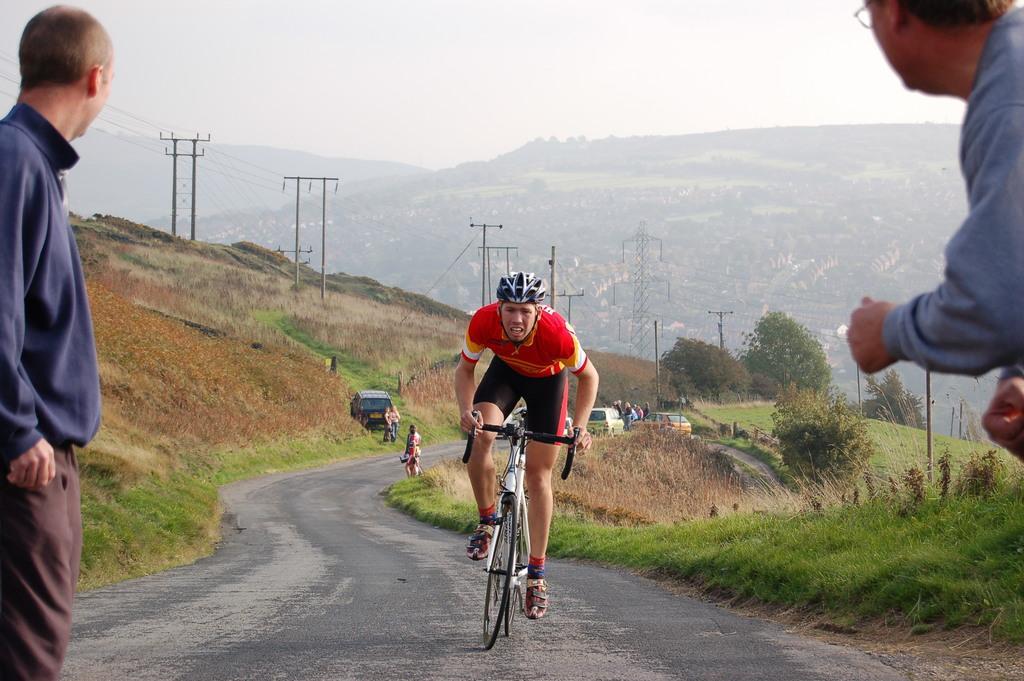Can you describe this image briefly? I can see the road and the person riding the bicycle wearing a helmet and red shirt and black shorts with the shoes on and to the corner left corner of the picture i could see another person standing and standing with the blue colored sweat shirt and maroon colored pant , this person is seeing the other side of the road and to right side of the corner also there is a person standing and looking towards the road. I could see some electrical cables and pipes running along the road side. There are big electrical poles towers on the roadside. There is a grass all over to the side of the road and some trees along the side of the roads. In the background i could see some hilly area covered with grass, trees and stones. In this picture in the back ground i could see the car parked over to the side of the road which is white in color and to the left side of the road i could see a black colored car parked. I could see one of the person standing along the right side of the road and a couple of people sitting in and standing near by the road side. 